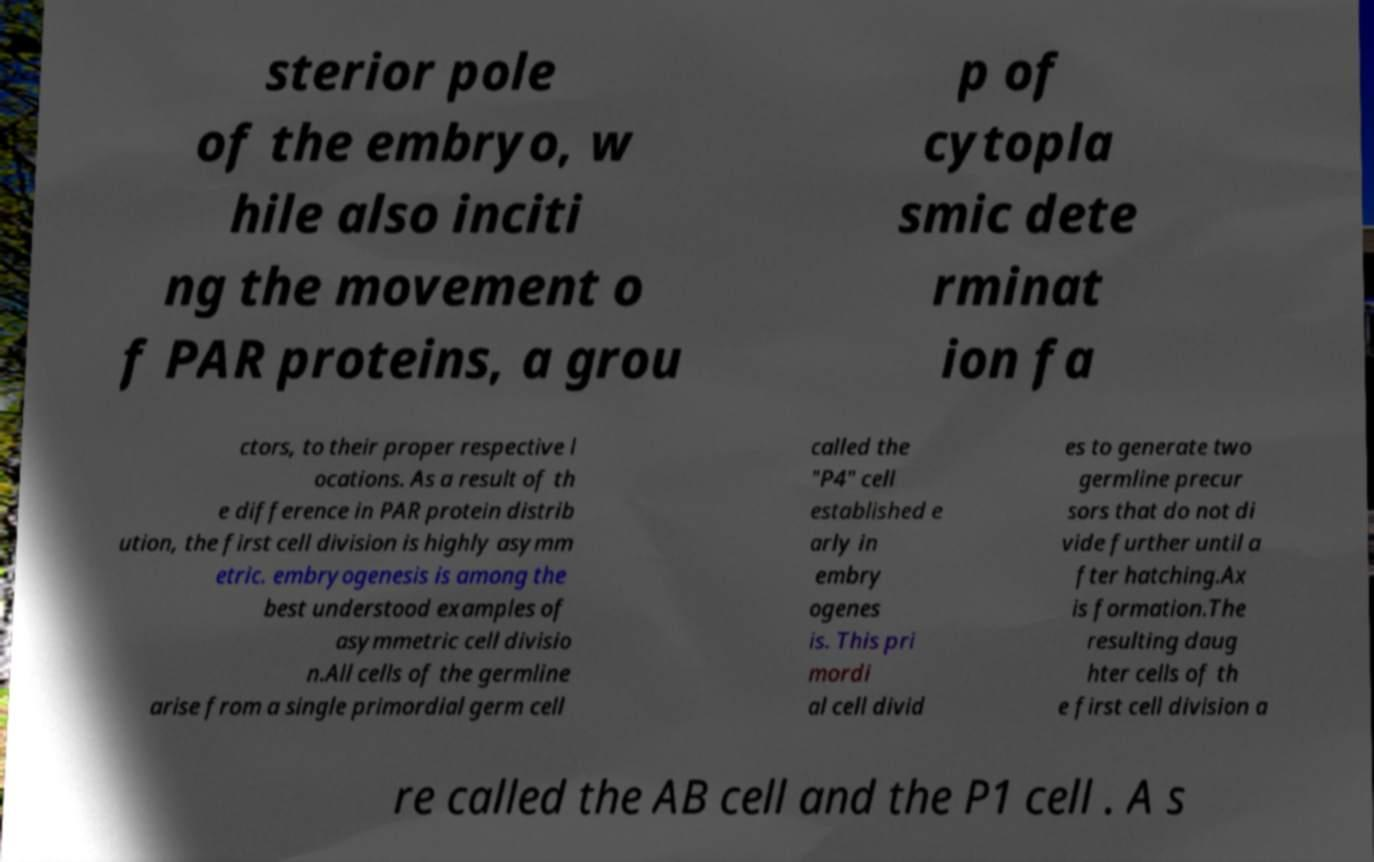Can you accurately transcribe the text from the provided image for me? sterior pole of the embryo, w hile also inciti ng the movement o f PAR proteins, a grou p of cytopla smic dete rminat ion fa ctors, to their proper respective l ocations. As a result of th e difference in PAR protein distrib ution, the first cell division is highly asymm etric. embryogenesis is among the best understood examples of asymmetric cell divisio n.All cells of the germline arise from a single primordial germ cell called the "P4" cell established e arly in embry ogenes is. This pri mordi al cell divid es to generate two germline precur sors that do not di vide further until a fter hatching.Ax is formation.The resulting daug hter cells of th e first cell division a re called the AB cell and the P1 cell . A s 